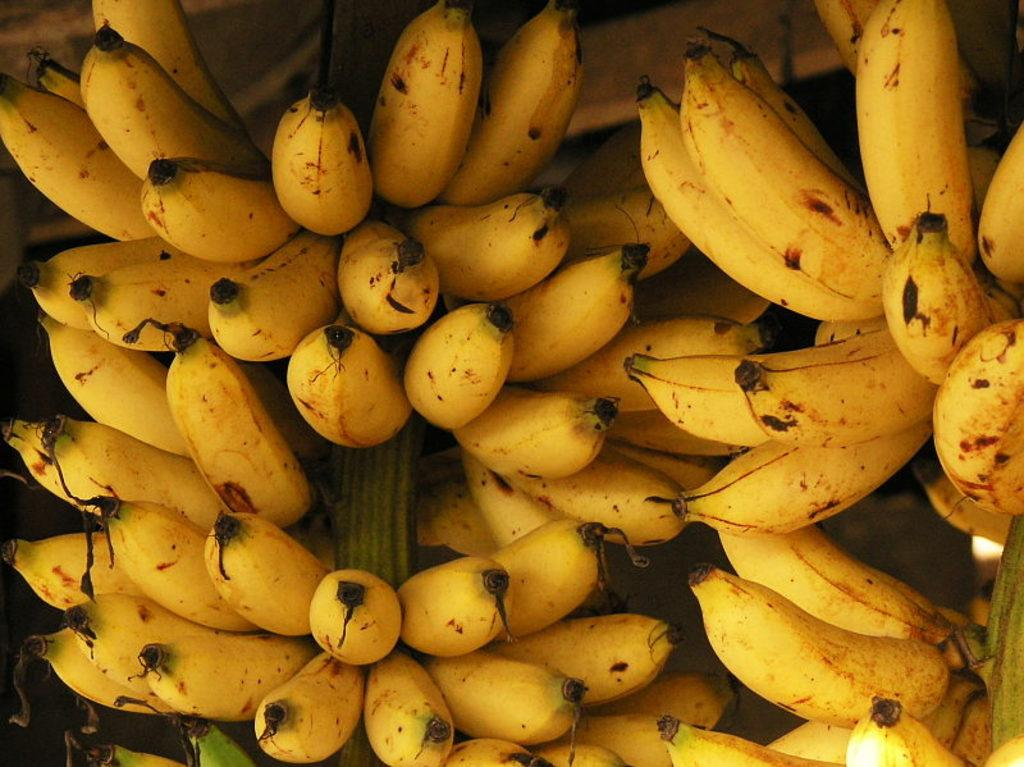What type of fruit is present in the image? There are bananas in the image. Can you describe the appearance of the bananas? The bananas appear to be yellow and curved. Are the bananas whole or cut in the image? The provided facts do not specify whether the bananas are whole or cut. What type of impulse can be seen affecting the fan in the image? There is no fan present in the image; it only features bananas. 